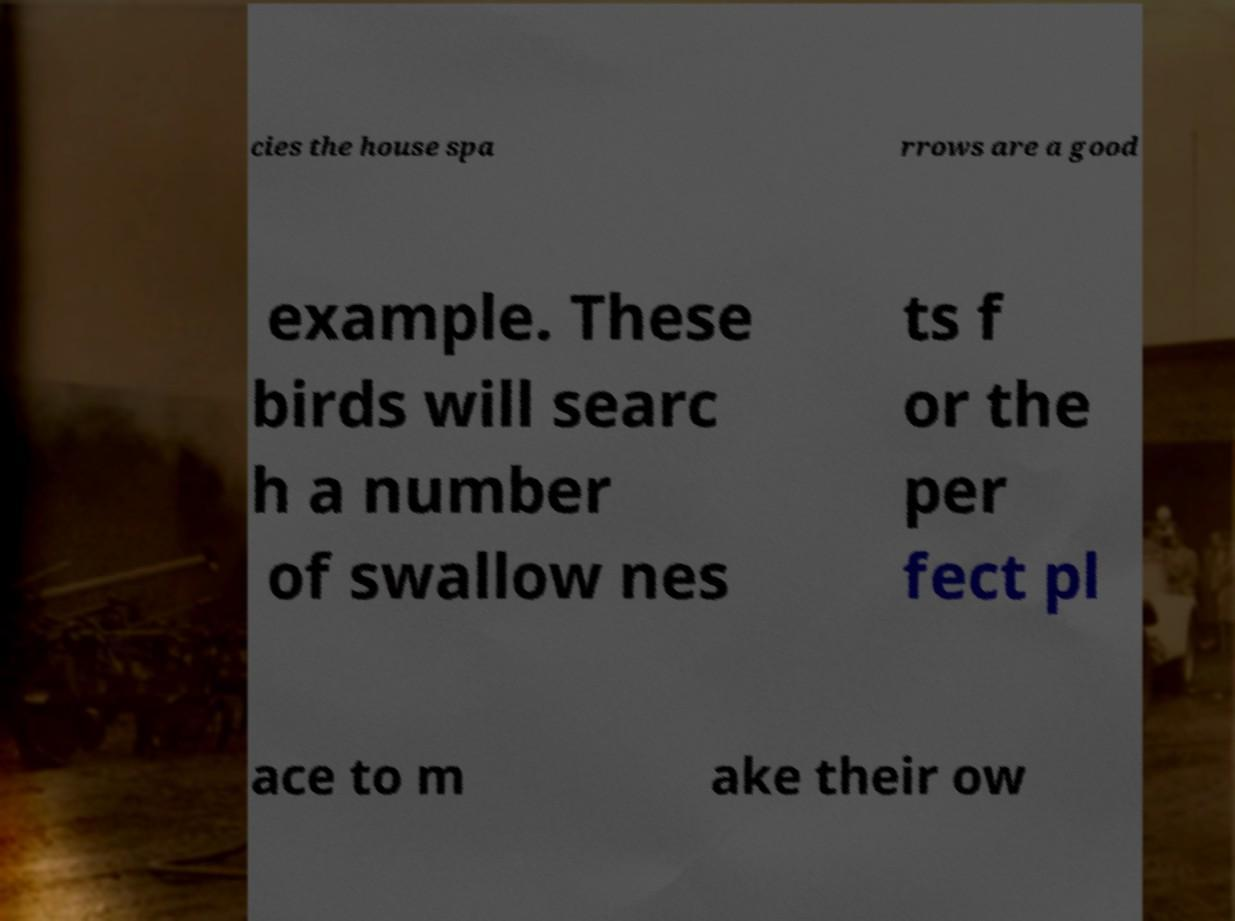Please read and relay the text visible in this image. What does it say? cies the house spa rrows are a good example. These birds will searc h a number of swallow nes ts f or the per fect pl ace to m ake their ow 